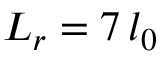<formula> <loc_0><loc_0><loc_500><loc_500>L _ { r } = 7 \, l _ { 0 }</formula> 